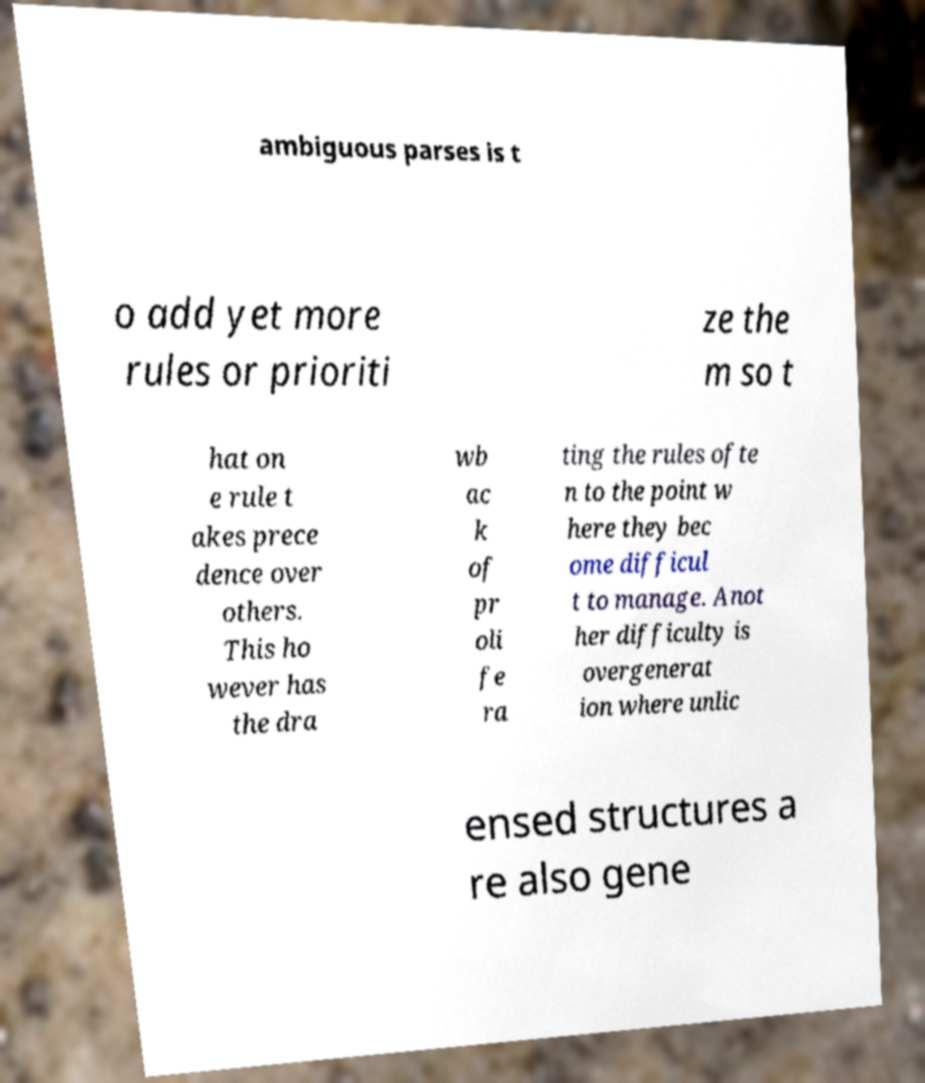Please identify and transcribe the text found in this image. ambiguous parses is t o add yet more rules or prioriti ze the m so t hat on e rule t akes prece dence over others. This ho wever has the dra wb ac k of pr oli fe ra ting the rules ofte n to the point w here they bec ome difficul t to manage. Anot her difficulty is overgenerat ion where unlic ensed structures a re also gene 